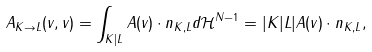Convert formula to latex. <formula><loc_0><loc_0><loc_500><loc_500>A _ { K \to L } ( v , v ) = \int _ { K | L } A ( v ) \cdot n _ { K , L } d \mathcal { H } ^ { N - 1 } = | K | L | A ( v ) \cdot n _ { K , L } ,</formula> 